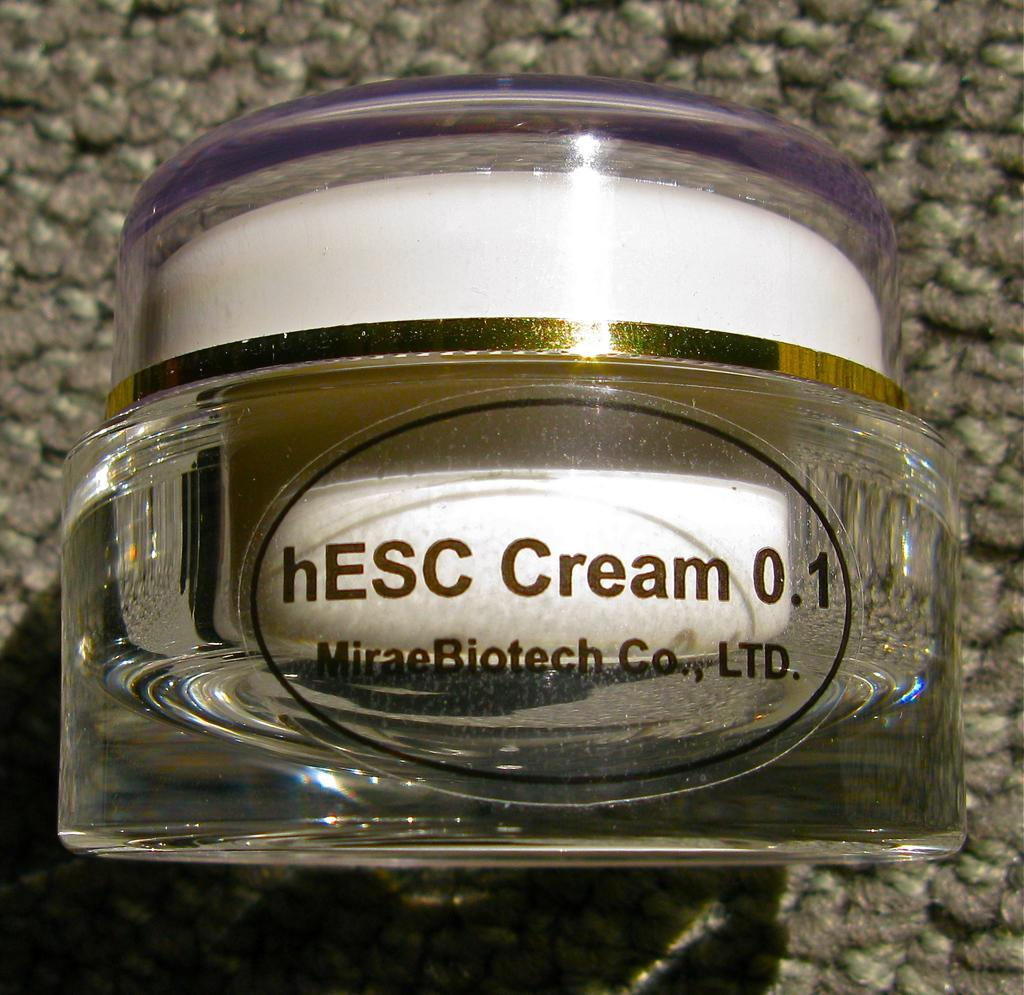<image>
Give a short and clear explanation of the subsequent image. A small bottle of cream rests on a carpet floor. 